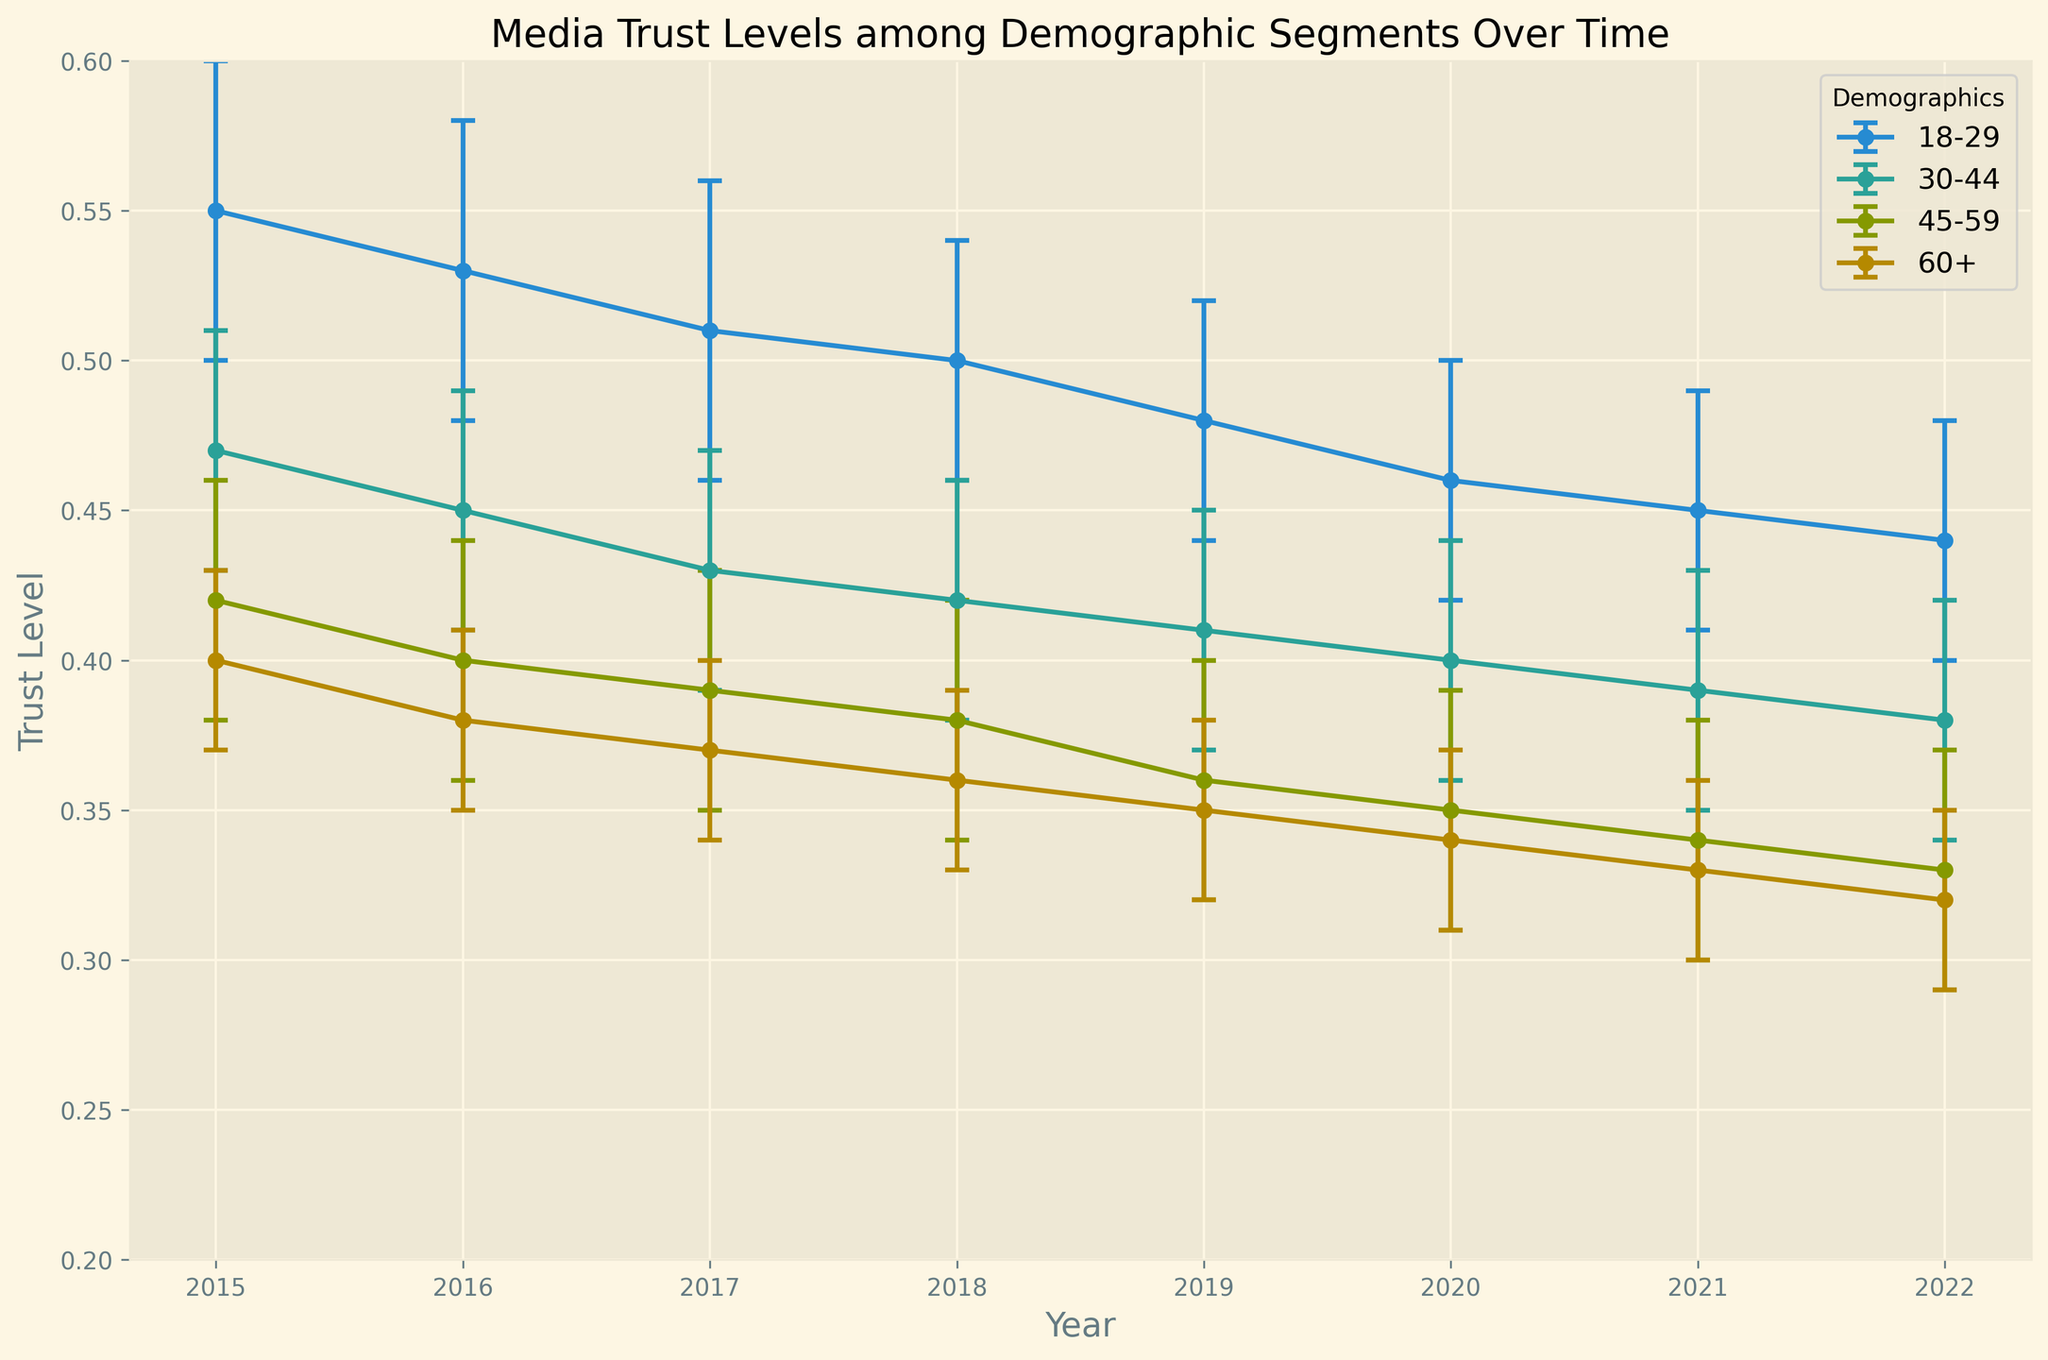What's the overall trend in trust levels for the 18-29 demographic from 2015 to 2022? Look at the line corresponding to the 18-29 demographic across the years. The trust level declines steadily from 0.55 in 2015 to 0.44 in 2022.
Answer: Decline Which demographic had the smallest decline in trust levels from 2015 to 2022? Calculate the difference in trust levels between 2015 and 2022 for each demographic. The 60+ group declined from 0.40 to 0.32, which is a difference of 0.08, the smallest among all demographics.
Answer: 60+ In what year did the 30-44 demographic’s trust level equal approximately 0.41? Look for the point on the 30-44 demographic's line where the trust level is around 0.41. This occurs in 2019.
Answer: 2019 What is the average trust level of the 45-59 demographic from 2015 to 2022? Calculate the average by summing the trust levels from 2015 to 2022 (0.42 + 0.40 + 0.39 + 0.38 + 0.36 + 0.35 + 0.34 + 0.33) and dividing by the number of years (8). (0.42 + 0.40 + 0.39 + 0.38 + 0.36 + 0.35 + 0.34 + 0.33)/8 = 2.97/8 = 0.37
Answer: 0.37 Which demographic had the highest trust level in 2017? Look at the points for 2017 and compare values. The 18-29 demographic had the highest trust level at 0.51.
Answer: 18-29 Does any demographic’s trust level fall below 0.30 at any point in the data? Look at the minimum values across all demographics from 2015 to 2022. None of the demographic groups fall below 0.30.
Answer: No Which two years have the largest gap in trust levels for the 60+ demographic? Compare the trust levels for the 60+ demographic year by year. The largest gap is from 2015 (0.40) to 2022 (0.32), a difference of 0.08.
Answer: 2015 and 2022 How does the error margin for the 45-59 demographic in 2020 compare to the 18-29 demographic in the same year? Look at the error margins for both demographics in 2020. The error margin is 0.04 for 45-59 and 0.04 for 18-29, which means they are equal.
Answer: Equal 